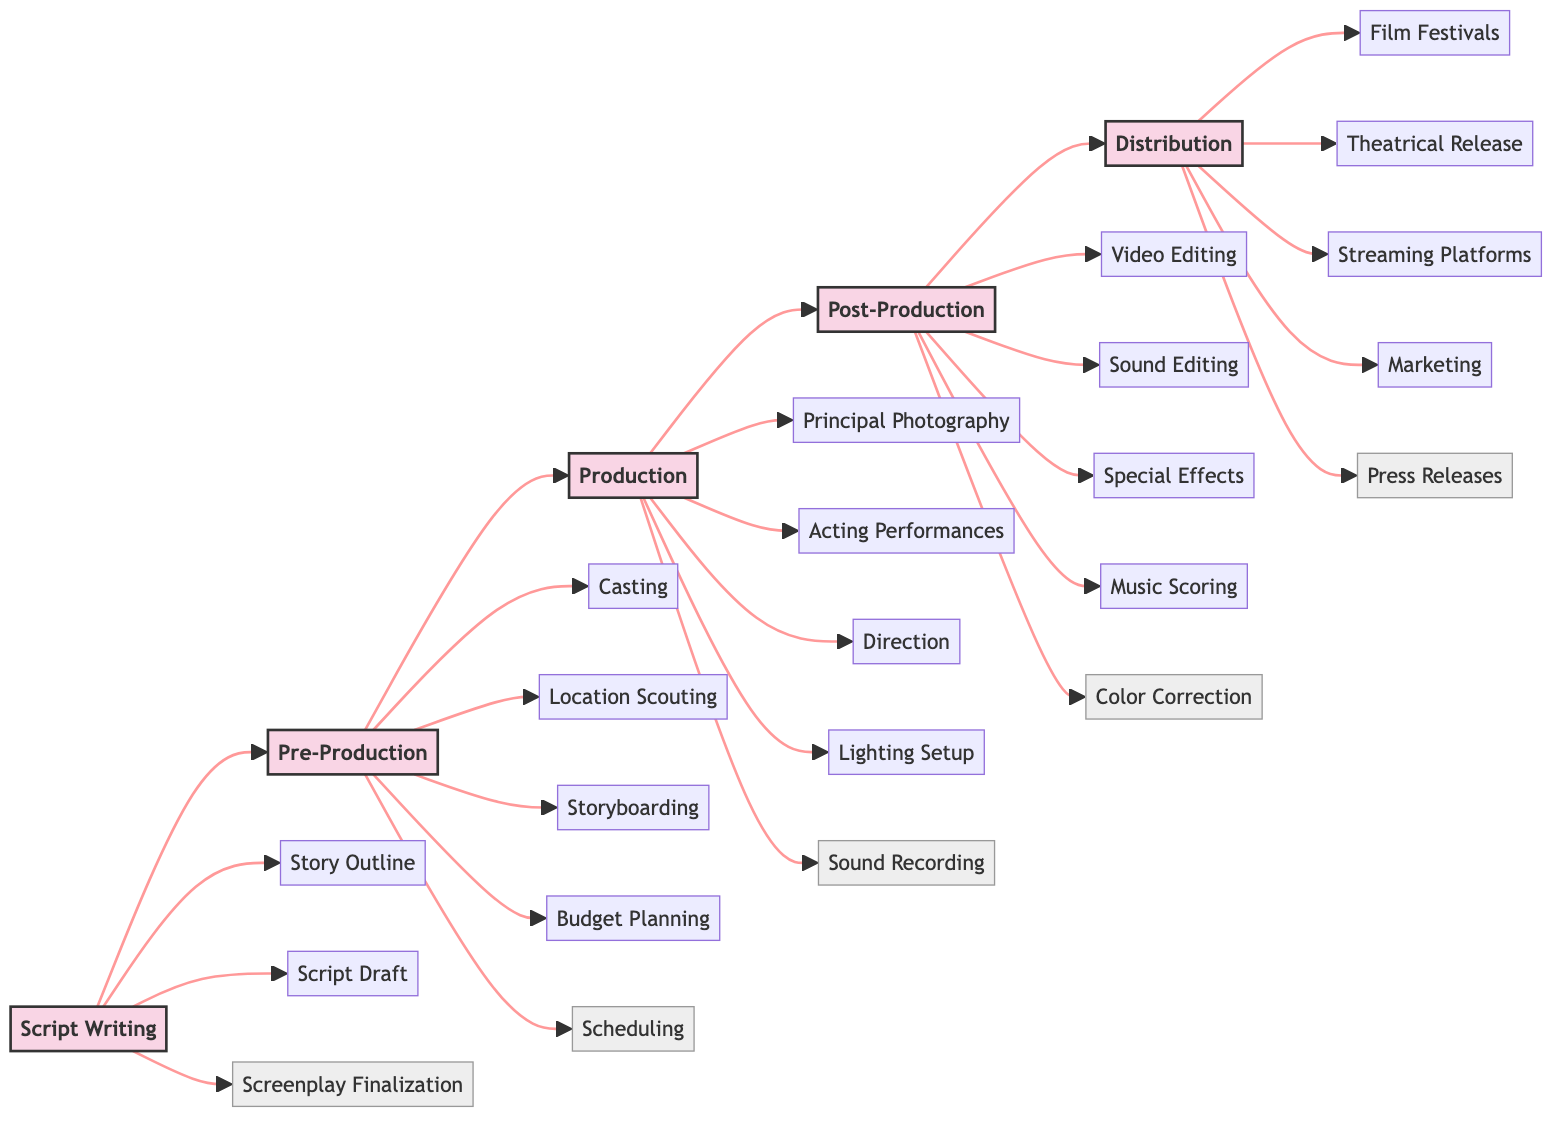What is the first stage in the film production workflow? The first stage in the workflow, as indicated in the diagram, is "Script Writing." This is found as the starting node on the left side of the flowchart.
Answer: Script Writing How many key elements are listed under Post-Production? The Post-Production stage lists five key elements: Video Editing, Sound Editing, Special Effects, Music Scoring, and Color Correction. Counting these elements gives the total of five.
Answer: 5 What stage comes after Pre-Production? The stage following Pre-Production, as shown in the flowchart, is Production. The arrows connecting the nodes demonstrate the sequence of stages.
Answer: Production Which key element is associated with the Pre-Production stage? One of the key elements associated with Pre-Production is "Casting." The elements under the Pre-Production node include several items, and "Casting" is one of them.
Answer: Casting What type of release is included in the Distribution stage? The Distribution stage includes "Theatrical Release" as one of its key elements. This can be identified directly from the nodes connected to the Distribution stage.
Answer: Theatrical Release Which stage involves the actual filming of the movie? The stage that involves the actual filming of the movie is the Production stage. This is explicitly stated as the phase where the film is shot, following the Pre-Production stage.
Answer: Production How many stages are there in total from Script to Distribution? There are five distinct stages depicted in the flowchart: Script Writing, Pre-Production, Production, Post-Production, and Distribution. Counting these stages gives the total.
Answer: 5 What connects the Script Writing stage to the Pre-Production stage? The arrow connecting Script Writing to Pre-Production indicates the flow from one stage to the next. This represents the progression in the film production workflow.
Answer: An arrow What is the final stage of the film production workflow? The final stage, as shown in the flowchart, is Distribution. It is the last node on the right side, indicating the completion of the workflow.
Answer: Distribution Which element signifies the concluding activities of the film production? The element that signifies concluding activities in the film production is "Press Releases" under the Distribution stage, indicating promotional efforts after the film is completed.
Answer: Press Releases 